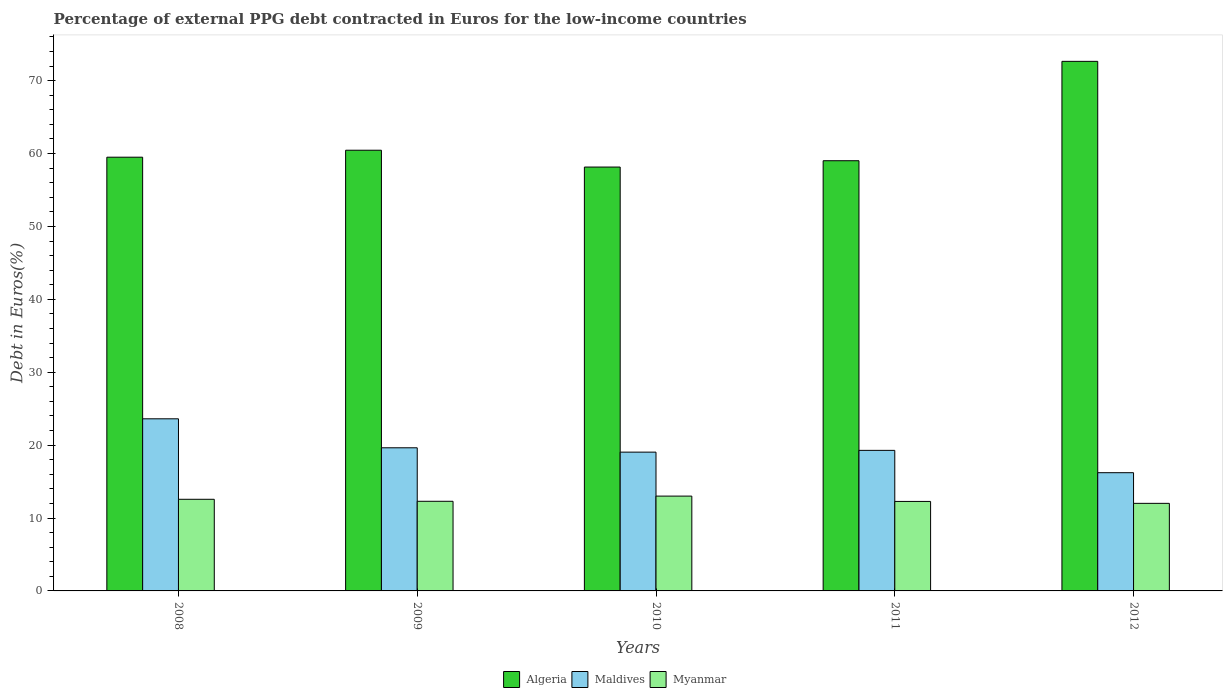How many different coloured bars are there?
Your answer should be compact. 3. How many groups of bars are there?
Offer a terse response. 5. Are the number of bars per tick equal to the number of legend labels?
Provide a short and direct response. Yes. Are the number of bars on each tick of the X-axis equal?
Keep it short and to the point. Yes. In how many cases, is the number of bars for a given year not equal to the number of legend labels?
Provide a short and direct response. 0. What is the percentage of external PPG debt contracted in Euros in Algeria in 2012?
Provide a succinct answer. 72.64. Across all years, what is the maximum percentage of external PPG debt contracted in Euros in Maldives?
Offer a very short reply. 23.61. Across all years, what is the minimum percentage of external PPG debt contracted in Euros in Algeria?
Keep it short and to the point. 58.15. What is the total percentage of external PPG debt contracted in Euros in Algeria in the graph?
Ensure brevity in your answer.  309.75. What is the difference between the percentage of external PPG debt contracted in Euros in Algeria in 2009 and that in 2010?
Keep it short and to the point. 2.31. What is the difference between the percentage of external PPG debt contracted in Euros in Myanmar in 2009 and the percentage of external PPG debt contracted in Euros in Algeria in 2012?
Your response must be concise. -60.35. What is the average percentage of external PPG debt contracted in Euros in Myanmar per year?
Offer a very short reply. 12.43. In the year 2009, what is the difference between the percentage of external PPG debt contracted in Euros in Myanmar and percentage of external PPG debt contracted in Euros in Algeria?
Your answer should be compact. -48.16. What is the ratio of the percentage of external PPG debt contracted in Euros in Algeria in 2008 to that in 2012?
Your answer should be very brief. 0.82. What is the difference between the highest and the second highest percentage of external PPG debt contracted in Euros in Myanmar?
Keep it short and to the point. 0.44. What is the difference between the highest and the lowest percentage of external PPG debt contracted in Euros in Algeria?
Offer a terse response. 14.5. Is the sum of the percentage of external PPG debt contracted in Euros in Algeria in 2010 and 2011 greater than the maximum percentage of external PPG debt contracted in Euros in Maldives across all years?
Your answer should be compact. Yes. What does the 1st bar from the left in 2012 represents?
Make the answer very short. Algeria. What does the 3rd bar from the right in 2010 represents?
Keep it short and to the point. Algeria. Is it the case that in every year, the sum of the percentage of external PPG debt contracted in Euros in Algeria and percentage of external PPG debt contracted in Euros in Maldives is greater than the percentage of external PPG debt contracted in Euros in Myanmar?
Give a very brief answer. Yes. How many bars are there?
Your response must be concise. 15. Are all the bars in the graph horizontal?
Offer a very short reply. No. Are the values on the major ticks of Y-axis written in scientific E-notation?
Provide a succinct answer. No. Does the graph contain any zero values?
Offer a terse response. No. Does the graph contain grids?
Provide a short and direct response. No. Where does the legend appear in the graph?
Your answer should be very brief. Bottom center. What is the title of the graph?
Ensure brevity in your answer.  Percentage of external PPG debt contracted in Euros for the low-income countries. What is the label or title of the X-axis?
Keep it short and to the point. Years. What is the label or title of the Y-axis?
Your answer should be very brief. Debt in Euros(%). What is the Debt in Euros(%) of Algeria in 2008?
Offer a very short reply. 59.5. What is the Debt in Euros(%) of Maldives in 2008?
Provide a succinct answer. 23.61. What is the Debt in Euros(%) of Myanmar in 2008?
Ensure brevity in your answer.  12.57. What is the Debt in Euros(%) of Algeria in 2009?
Your answer should be compact. 60.45. What is the Debt in Euros(%) in Maldives in 2009?
Provide a succinct answer. 19.63. What is the Debt in Euros(%) in Myanmar in 2009?
Offer a very short reply. 12.3. What is the Debt in Euros(%) in Algeria in 2010?
Make the answer very short. 58.15. What is the Debt in Euros(%) in Maldives in 2010?
Provide a short and direct response. 19.04. What is the Debt in Euros(%) in Myanmar in 2010?
Keep it short and to the point. 13.01. What is the Debt in Euros(%) of Algeria in 2011?
Your answer should be compact. 59.01. What is the Debt in Euros(%) of Maldives in 2011?
Your answer should be compact. 19.28. What is the Debt in Euros(%) of Myanmar in 2011?
Give a very brief answer. 12.28. What is the Debt in Euros(%) in Algeria in 2012?
Give a very brief answer. 72.64. What is the Debt in Euros(%) in Maldives in 2012?
Your answer should be compact. 16.22. What is the Debt in Euros(%) in Myanmar in 2012?
Ensure brevity in your answer.  12.01. Across all years, what is the maximum Debt in Euros(%) in Algeria?
Your answer should be compact. 72.64. Across all years, what is the maximum Debt in Euros(%) in Maldives?
Your answer should be very brief. 23.61. Across all years, what is the maximum Debt in Euros(%) of Myanmar?
Your response must be concise. 13.01. Across all years, what is the minimum Debt in Euros(%) in Algeria?
Give a very brief answer. 58.15. Across all years, what is the minimum Debt in Euros(%) in Maldives?
Your response must be concise. 16.22. Across all years, what is the minimum Debt in Euros(%) in Myanmar?
Your answer should be very brief. 12.01. What is the total Debt in Euros(%) in Algeria in the graph?
Provide a succinct answer. 309.75. What is the total Debt in Euros(%) in Maldives in the graph?
Offer a very short reply. 97.78. What is the total Debt in Euros(%) in Myanmar in the graph?
Your answer should be compact. 62.16. What is the difference between the Debt in Euros(%) in Algeria in 2008 and that in 2009?
Ensure brevity in your answer.  -0.96. What is the difference between the Debt in Euros(%) of Maldives in 2008 and that in 2009?
Make the answer very short. 3.98. What is the difference between the Debt in Euros(%) in Myanmar in 2008 and that in 2009?
Ensure brevity in your answer.  0.27. What is the difference between the Debt in Euros(%) of Algeria in 2008 and that in 2010?
Your response must be concise. 1.35. What is the difference between the Debt in Euros(%) of Maldives in 2008 and that in 2010?
Your answer should be compact. 4.57. What is the difference between the Debt in Euros(%) of Myanmar in 2008 and that in 2010?
Your answer should be very brief. -0.44. What is the difference between the Debt in Euros(%) in Algeria in 2008 and that in 2011?
Your response must be concise. 0.48. What is the difference between the Debt in Euros(%) of Maldives in 2008 and that in 2011?
Make the answer very short. 4.33. What is the difference between the Debt in Euros(%) in Myanmar in 2008 and that in 2011?
Give a very brief answer. 0.29. What is the difference between the Debt in Euros(%) of Algeria in 2008 and that in 2012?
Ensure brevity in your answer.  -13.15. What is the difference between the Debt in Euros(%) in Maldives in 2008 and that in 2012?
Keep it short and to the point. 7.39. What is the difference between the Debt in Euros(%) of Myanmar in 2008 and that in 2012?
Offer a very short reply. 0.56. What is the difference between the Debt in Euros(%) in Algeria in 2009 and that in 2010?
Your response must be concise. 2.31. What is the difference between the Debt in Euros(%) of Maldives in 2009 and that in 2010?
Ensure brevity in your answer.  0.6. What is the difference between the Debt in Euros(%) in Myanmar in 2009 and that in 2010?
Make the answer very short. -0.71. What is the difference between the Debt in Euros(%) of Algeria in 2009 and that in 2011?
Your response must be concise. 1.44. What is the difference between the Debt in Euros(%) in Maldives in 2009 and that in 2011?
Offer a terse response. 0.35. What is the difference between the Debt in Euros(%) in Myanmar in 2009 and that in 2011?
Your response must be concise. 0.02. What is the difference between the Debt in Euros(%) in Algeria in 2009 and that in 2012?
Offer a very short reply. -12.19. What is the difference between the Debt in Euros(%) in Maldives in 2009 and that in 2012?
Your answer should be very brief. 3.42. What is the difference between the Debt in Euros(%) in Myanmar in 2009 and that in 2012?
Provide a succinct answer. 0.28. What is the difference between the Debt in Euros(%) in Algeria in 2010 and that in 2011?
Your answer should be very brief. -0.87. What is the difference between the Debt in Euros(%) in Maldives in 2010 and that in 2011?
Offer a terse response. -0.24. What is the difference between the Debt in Euros(%) of Myanmar in 2010 and that in 2011?
Your answer should be compact. 0.73. What is the difference between the Debt in Euros(%) in Algeria in 2010 and that in 2012?
Offer a terse response. -14.5. What is the difference between the Debt in Euros(%) of Maldives in 2010 and that in 2012?
Ensure brevity in your answer.  2.82. What is the difference between the Debt in Euros(%) of Myanmar in 2010 and that in 2012?
Keep it short and to the point. 0.99. What is the difference between the Debt in Euros(%) in Algeria in 2011 and that in 2012?
Make the answer very short. -13.63. What is the difference between the Debt in Euros(%) of Maldives in 2011 and that in 2012?
Your answer should be compact. 3.06. What is the difference between the Debt in Euros(%) of Myanmar in 2011 and that in 2012?
Make the answer very short. 0.26. What is the difference between the Debt in Euros(%) of Algeria in 2008 and the Debt in Euros(%) of Maldives in 2009?
Give a very brief answer. 39.86. What is the difference between the Debt in Euros(%) in Algeria in 2008 and the Debt in Euros(%) in Myanmar in 2009?
Offer a very short reply. 47.2. What is the difference between the Debt in Euros(%) in Maldives in 2008 and the Debt in Euros(%) in Myanmar in 2009?
Keep it short and to the point. 11.31. What is the difference between the Debt in Euros(%) in Algeria in 2008 and the Debt in Euros(%) in Maldives in 2010?
Your answer should be compact. 40.46. What is the difference between the Debt in Euros(%) of Algeria in 2008 and the Debt in Euros(%) of Myanmar in 2010?
Ensure brevity in your answer.  46.49. What is the difference between the Debt in Euros(%) in Maldives in 2008 and the Debt in Euros(%) in Myanmar in 2010?
Provide a succinct answer. 10.6. What is the difference between the Debt in Euros(%) in Algeria in 2008 and the Debt in Euros(%) in Maldives in 2011?
Offer a terse response. 40.22. What is the difference between the Debt in Euros(%) of Algeria in 2008 and the Debt in Euros(%) of Myanmar in 2011?
Your answer should be very brief. 47.22. What is the difference between the Debt in Euros(%) of Maldives in 2008 and the Debt in Euros(%) of Myanmar in 2011?
Ensure brevity in your answer.  11.33. What is the difference between the Debt in Euros(%) of Algeria in 2008 and the Debt in Euros(%) of Maldives in 2012?
Offer a very short reply. 43.28. What is the difference between the Debt in Euros(%) of Algeria in 2008 and the Debt in Euros(%) of Myanmar in 2012?
Provide a short and direct response. 47.48. What is the difference between the Debt in Euros(%) of Maldives in 2008 and the Debt in Euros(%) of Myanmar in 2012?
Provide a succinct answer. 11.6. What is the difference between the Debt in Euros(%) in Algeria in 2009 and the Debt in Euros(%) in Maldives in 2010?
Provide a short and direct response. 41.41. What is the difference between the Debt in Euros(%) in Algeria in 2009 and the Debt in Euros(%) in Myanmar in 2010?
Your answer should be very brief. 47.44. What is the difference between the Debt in Euros(%) of Maldives in 2009 and the Debt in Euros(%) of Myanmar in 2010?
Ensure brevity in your answer.  6.63. What is the difference between the Debt in Euros(%) of Algeria in 2009 and the Debt in Euros(%) of Maldives in 2011?
Keep it short and to the point. 41.17. What is the difference between the Debt in Euros(%) in Algeria in 2009 and the Debt in Euros(%) in Myanmar in 2011?
Make the answer very short. 48.18. What is the difference between the Debt in Euros(%) of Maldives in 2009 and the Debt in Euros(%) of Myanmar in 2011?
Make the answer very short. 7.36. What is the difference between the Debt in Euros(%) of Algeria in 2009 and the Debt in Euros(%) of Maldives in 2012?
Provide a short and direct response. 44.24. What is the difference between the Debt in Euros(%) in Algeria in 2009 and the Debt in Euros(%) in Myanmar in 2012?
Keep it short and to the point. 48.44. What is the difference between the Debt in Euros(%) in Maldives in 2009 and the Debt in Euros(%) in Myanmar in 2012?
Ensure brevity in your answer.  7.62. What is the difference between the Debt in Euros(%) in Algeria in 2010 and the Debt in Euros(%) in Maldives in 2011?
Provide a short and direct response. 38.87. What is the difference between the Debt in Euros(%) in Algeria in 2010 and the Debt in Euros(%) in Myanmar in 2011?
Provide a succinct answer. 45.87. What is the difference between the Debt in Euros(%) in Maldives in 2010 and the Debt in Euros(%) in Myanmar in 2011?
Offer a very short reply. 6.76. What is the difference between the Debt in Euros(%) in Algeria in 2010 and the Debt in Euros(%) in Maldives in 2012?
Your response must be concise. 41.93. What is the difference between the Debt in Euros(%) in Algeria in 2010 and the Debt in Euros(%) in Myanmar in 2012?
Give a very brief answer. 46.13. What is the difference between the Debt in Euros(%) of Maldives in 2010 and the Debt in Euros(%) of Myanmar in 2012?
Give a very brief answer. 7.03. What is the difference between the Debt in Euros(%) of Algeria in 2011 and the Debt in Euros(%) of Maldives in 2012?
Ensure brevity in your answer.  42.8. What is the difference between the Debt in Euros(%) in Algeria in 2011 and the Debt in Euros(%) in Myanmar in 2012?
Your response must be concise. 47. What is the difference between the Debt in Euros(%) of Maldives in 2011 and the Debt in Euros(%) of Myanmar in 2012?
Make the answer very short. 7.27. What is the average Debt in Euros(%) of Algeria per year?
Offer a very short reply. 61.95. What is the average Debt in Euros(%) of Maldives per year?
Provide a succinct answer. 19.56. What is the average Debt in Euros(%) in Myanmar per year?
Provide a succinct answer. 12.43. In the year 2008, what is the difference between the Debt in Euros(%) of Algeria and Debt in Euros(%) of Maldives?
Provide a short and direct response. 35.89. In the year 2008, what is the difference between the Debt in Euros(%) in Algeria and Debt in Euros(%) in Myanmar?
Keep it short and to the point. 46.93. In the year 2008, what is the difference between the Debt in Euros(%) in Maldives and Debt in Euros(%) in Myanmar?
Provide a short and direct response. 11.04. In the year 2009, what is the difference between the Debt in Euros(%) of Algeria and Debt in Euros(%) of Maldives?
Your answer should be very brief. 40.82. In the year 2009, what is the difference between the Debt in Euros(%) of Algeria and Debt in Euros(%) of Myanmar?
Provide a short and direct response. 48.16. In the year 2009, what is the difference between the Debt in Euros(%) in Maldives and Debt in Euros(%) in Myanmar?
Make the answer very short. 7.34. In the year 2010, what is the difference between the Debt in Euros(%) in Algeria and Debt in Euros(%) in Maldives?
Offer a terse response. 39.11. In the year 2010, what is the difference between the Debt in Euros(%) in Algeria and Debt in Euros(%) in Myanmar?
Your answer should be very brief. 45.14. In the year 2010, what is the difference between the Debt in Euros(%) in Maldives and Debt in Euros(%) in Myanmar?
Give a very brief answer. 6.03. In the year 2011, what is the difference between the Debt in Euros(%) of Algeria and Debt in Euros(%) of Maldives?
Make the answer very short. 39.73. In the year 2011, what is the difference between the Debt in Euros(%) in Algeria and Debt in Euros(%) in Myanmar?
Your answer should be very brief. 46.74. In the year 2011, what is the difference between the Debt in Euros(%) in Maldives and Debt in Euros(%) in Myanmar?
Ensure brevity in your answer.  7. In the year 2012, what is the difference between the Debt in Euros(%) in Algeria and Debt in Euros(%) in Maldives?
Give a very brief answer. 56.43. In the year 2012, what is the difference between the Debt in Euros(%) of Algeria and Debt in Euros(%) of Myanmar?
Offer a very short reply. 60.63. In the year 2012, what is the difference between the Debt in Euros(%) in Maldives and Debt in Euros(%) in Myanmar?
Your response must be concise. 4.2. What is the ratio of the Debt in Euros(%) in Algeria in 2008 to that in 2009?
Give a very brief answer. 0.98. What is the ratio of the Debt in Euros(%) in Maldives in 2008 to that in 2009?
Give a very brief answer. 1.2. What is the ratio of the Debt in Euros(%) in Myanmar in 2008 to that in 2009?
Offer a very short reply. 1.02. What is the ratio of the Debt in Euros(%) in Algeria in 2008 to that in 2010?
Make the answer very short. 1.02. What is the ratio of the Debt in Euros(%) of Maldives in 2008 to that in 2010?
Ensure brevity in your answer.  1.24. What is the ratio of the Debt in Euros(%) of Myanmar in 2008 to that in 2010?
Ensure brevity in your answer.  0.97. What is the ratio of the Debt in Euros(%) in Algeria in 2008 to that in 2011?
Provide a succinct answer. 1.01. What is the ratio of the Debt in Euros(%) in Maldives in 2008 to that in 2011?
Your response must be concise. 1.22. What is the ratio of the Debt in Euros(%) of Myanmar in 2008 to that in 2011?
Give a very brief answer. 1.02. What is the ratio of the Debt in Euros(%) in Algeria in 2008 to that in 2012?
Provide a succinct answer. 0.82. What is the ratio of the Debt in Euros(%) of Maldives in 2008 to that in 2012?
Give a very brief answer. 1.46. What is the ratio of the Debt in Euros(%) in Myanmar in 2008 to that in 2012?
Offer a very short reply. 1.05. What is the ratio of the Debt in Euros(%) of Algeria in 2009 to that in 2010?
Offer a very short reply. 1.04. What is the ratio of the Debt in Euros(%) of Maldives in 2009 to that in 2010?
Offer a very short reply. 1.03. What is the ratio of the Debt in Euros(%) of Myanmar in 2009 to that in 2010?
Give a very brief answer. 0.95. What is the ratio of the Debt in Euros(%) in Algeria in 2009 to that in 2011?
Ensure brevity in your answer.  1.02. What is the ratio of the Debt in Euros(%) in Maldives in 2009 to that in 2011?
Your answer should be compact. 1.02. What is the ratio of the Debt in Euros(%) of Algeria in 2009 to that in 2012?
Make the answer very short. 0.83. What is the ratio of the Debt in Euros(%) in Maldives in 2009 to that in 2012?
Offer a very short reply. 1.21. What is the ratio of the Debt in Euros(%) of Myanmar in 2009 to that in 2012?
Provide a succinct answer. 1.02. What is the ratio of the Debt in Euros(%) in Algeria in 2010 to that in 2011?
Provide a short and direct response. 0.99. What is the ratio of the Debt in Euros(%) of Maldives in 2010 to that in 2011?
Provide a succinct answer. 0.99. What is the ratio of the Debt in Euros(%) of Myanmar in 2010 to that in 2011?
Your answer should be very brief. 1.06. What is the ratio of the Debt in Euros(%) in Algeria in 2010 to that in 2012?
Offer a terse response. 0.8. What is the ratio of the Debt in Euros(%) of Maldives in 2010 to that in 2012?
Provide a short and direct response. 1.17. What is the ratio of the Debt in Euros(%) in Myanmar in 2010 to that in 2012?
Keep it short and to the point. 1.08. What is the ratio of the Debt in Euros(%) of Algeria in 2011 to that in 2012?
Give a very brief answer. 0.81. What is the ratio of the Debt in Euros(%) of Maldives in 2011 to that in 2012?
Offer a terse response. 1.19. What is the ratio of the Debt in Euros(%) of Myanmar in 2011 to that in 2012?
Keep it short and to the point. 1.02. What is the difference between the highest and the second highest Debt in Euros(%) in Algeria?
Your response must be concise. 12.19. What is the difference between the highest and the second highest Debt in Euros(%) in Maldives?
Your response must be concise. 3.98. What is the difference between the highest and the second highest Debt in Euros(%) in Myanmar?
Offer a very short reply. 0.44. What is the difference between the highest and the lowest Debt in Euros(%) of Algeria?
Give a very brief answer. 14.5. What is the difference between the highest and the lowest Debt in Euros(%) in Maldives?
Provide a succinct answer. 7.39. 